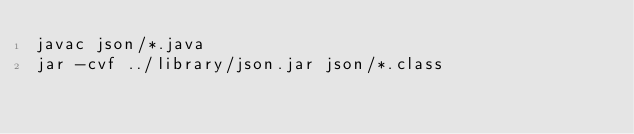Convert code to text. <code><loc_0><loc_0><loc_500><loc_500><_Bash_>javac json/*.java
jar -cvf ../library/json.jar json/*.class
</code> 